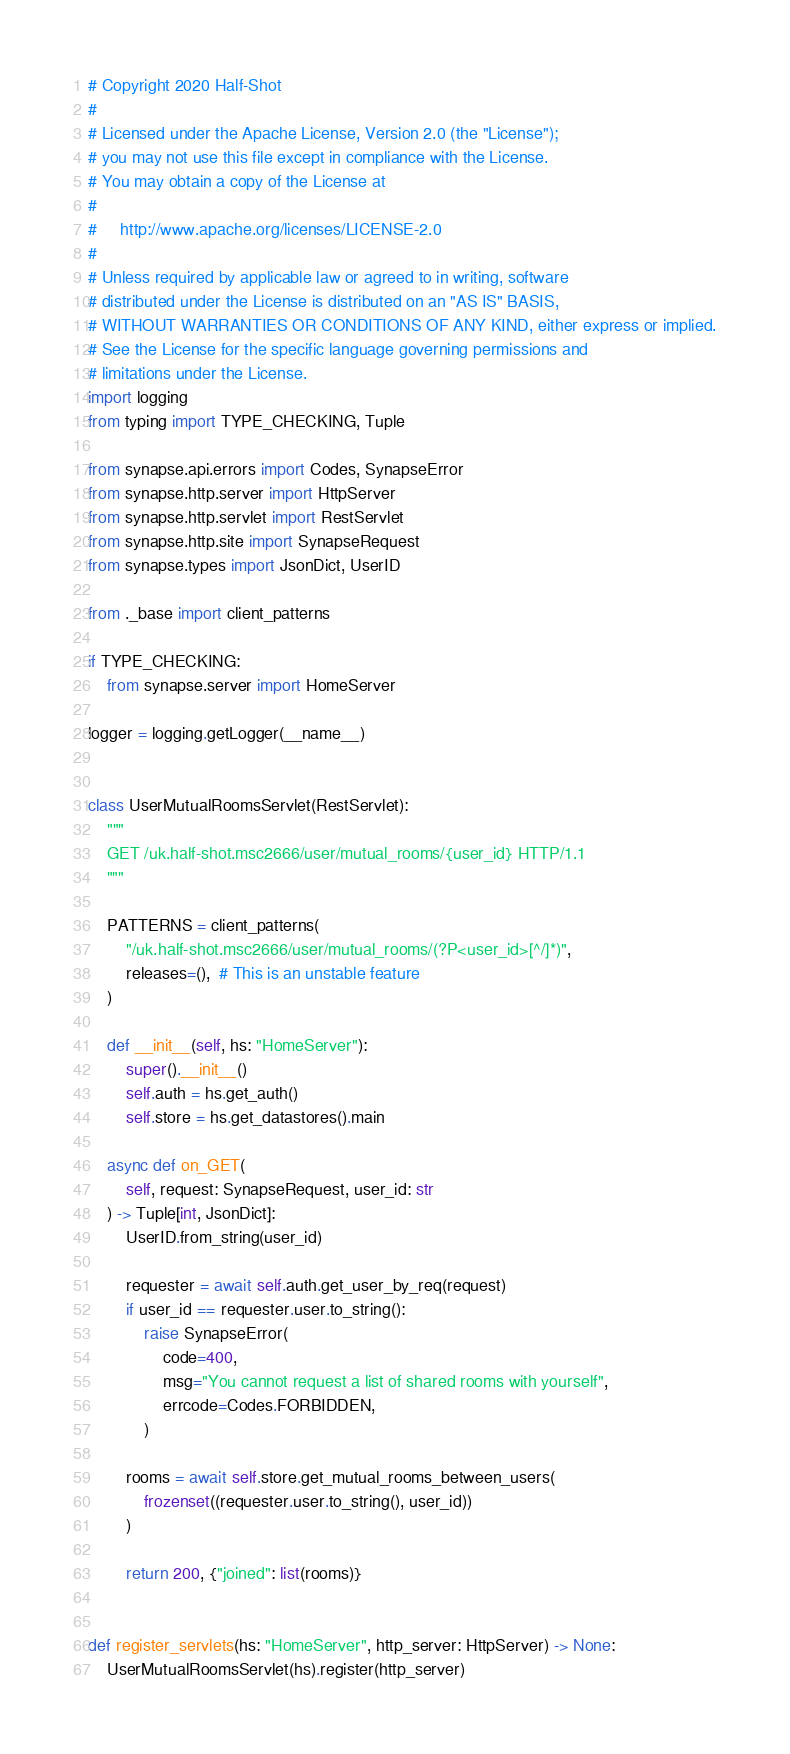<code> <loc_0><loc_0><loc_500><loc_500><_Python_># Copyright 2020 Half-Shot
#
# Licensed under the Apache License, Version 2.0 (the "License");
# you may not use this file except in compliance with the License.
# You may obtain a copy of the License at
#
#     http://www.apache.org/licenses/LICENSE-2.0
#
# Unless required by applicable law or agreed to in writing, software
# distributed under the License is distributed on an "AS IS" BASIS,
# WITHOUT WARRANTIES OR CONDITIONS OF ANY KIND, either express or implied.
# See the License for the specific language governing permissions and
# limitations under the License.
import logging
from typing import TYPE_CHECKING, Tuple

from synapse.api.errors import Codes, SynapseError
from synapse.http.server import HttpServer
from synapse.http.servlet import RestServlet
from synapse.http.site import SynapseRequest
from synapse.types import JsonDict, UserID

from ._base import client_patterns

if TYPE_CHECKING:
    from synapse.server import HomeServer

logger = logging.getLogger(__name__)


class UserMutualRoomsServlet(RestServlet):
    """
    GET /uk.half-shot.msc2666/user/mutual_rooms/{user_id} HTTP/1.1
    """

    PATTERNS = client_patterns(
        "/uk.half-shot.msc2666/user/mutual_rooms/(?P<user_id>[^/]*)",
        releases=(),  # This is an unstable feature
    )

    def __init__(self, hs: "HomeServer"):
        super().__init__()
        self.auth = hs.get_auth()
        self.store = hs.get_datastores().main

    async def on_GET(
        self, request: SynapseRequest, user_id: str
    ) -> Tuple[int, JsonDict]:
        UserID.from_string(user_id)

        requester = await self.auth.get_user_by_req(request)
        if user_id == requester.user.to_string():
            raise SynapseError(
                code=400,
                msg="You cannot request a list of shared rooms with yourself",
                errcode=Codes.FORBIDDEN,
            )

        rooms = await self.store.get_mutual_rooms_between_users(
            frozenset((requester.user.to_string(), user_id))
        )

        return 200, {"joined": list(rooms)}


def register_servlets(hs: "HomeServer", http_server: HttpServer) -> None:
    UserMutualRoomsServlet(hs).register(http_server)
</code> 